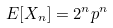<formula> <loc_0><loc_0><loc_500><loc_500>E [ X _ { n } ] = 2 ^ { n } p ^ { n }</formula> 